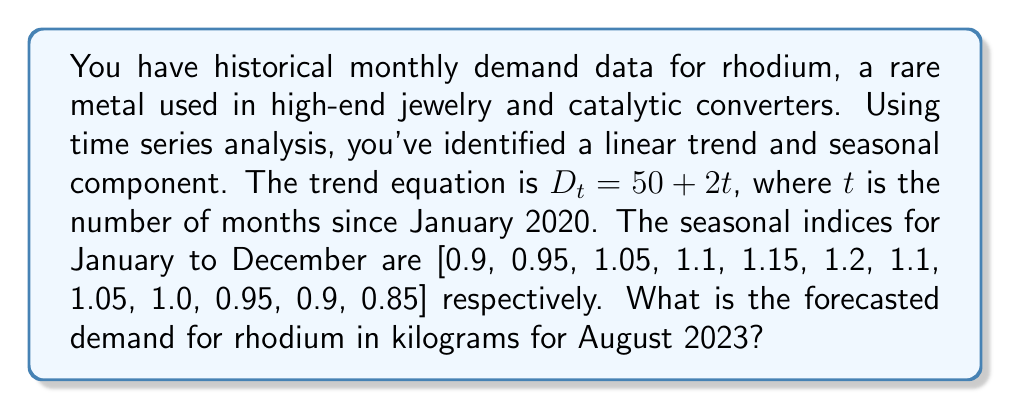Can you answer this question? To forecast the demand for rhodium in August 2023, we need to follow these steps:

1. Determine the value of $t$ for August 2023:
   - January 2020 is $t = 0$
   - August 2023 is 43 months later, so $t = 43$

2. Calculate the trend component using the equation $D_t = 50 + 2t$:
   $D_{43} = 50 + 2(43) = 50 + 86 = 136$

3. Identify the seasonal index for August:
   - August is the 8th month, so we use the 8th index: 1.05

4. Multiply the trend component by the seasonal index:
   Forecasted demand = Trend × Seasonal Index
   $= 136 \times 1.05 = 142.8$

Therefore, the forecasted demand for rhodium in August 2023 is 142.8 kilograms.
Answer: 142.8 kg 